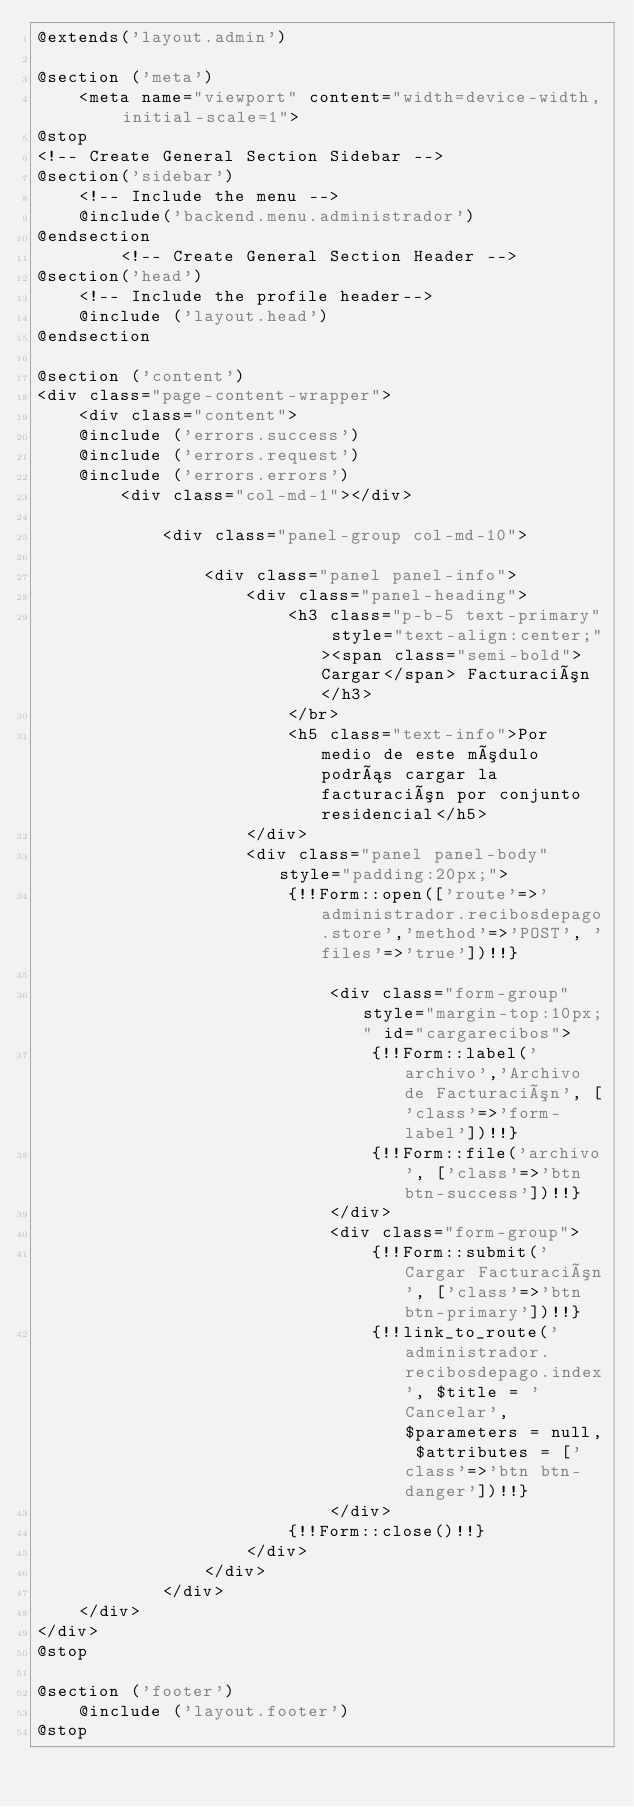Convert code to text. <code><loc_0><loc_0><loc_500><loc_500><_PHP_>@extends('layout.admin')

@section ('meta')
    <meta name="viewport" content="width=device-width, initial-scale=1">
@stop
<!-- Create General Section Sidebar -->
@section('sidebar')
    <!-- Include the menu -->
    @include('backend.menu.administrador')
@endsection
        <!-- Create General Section Header -->
@section('head')
    <!-- Include the profile header--> 
    @include ('layout.head')
@endsection

@section ('content')
<div class="page-content-wrapper">
    <div class="content">
    @include ('errors.success')
    @include ('errors.request')
    @include ('errors.errors')          
        <div class="col-md-1"></div>

            <div class="panel-group col-md-10">

                <div class="panel panel-info">
                    <div class="panel-heading">
                        <h3 class="p-b-5 text-primary" style="text-align:center;"><span class="semi-bold">Cargar</span> Facturación</h3>
                        </br>
                        <h5 class="text-info">Por medio de este módulo podrás cargar la facturación por conjunto residencial</h5>
                    </div>
                    <div class="panel panel-body" style="padding:20px;">
                        {!!Form::open(['route'=>'administrador.recibosdepago.store','method'=>'POST', 'files'=>'true'])!!}
                            
                            <div class="form-group" style="margin-top:10px;" id="cargarecibos">
                                {!!Form::label('archivo','Archivo de Facturación', ['class'=>'form-label'])!!}
                                {!!Form::file('archivo', ['class'=>'btn btn-success'])!!}
                            </div>
                            <div class="form-group">
                                {!!Form::submit('Cargar Facturación', ['class'=>'btn btn-primary'])!!}
                                {!!link_to_route('administrador.recibosdepago.index', $title = 'Cancelar', $parameters = null, $attributes = ['class'=>'btn btn-danger'])!!}                        
                            </div>
                        {!!Form::close()!!}
                    </div>
                </div>
            </div>                  
    </div>
</div>
@stop

@section ('footer')
    @include ('layout.footer')
@stop
</code> 